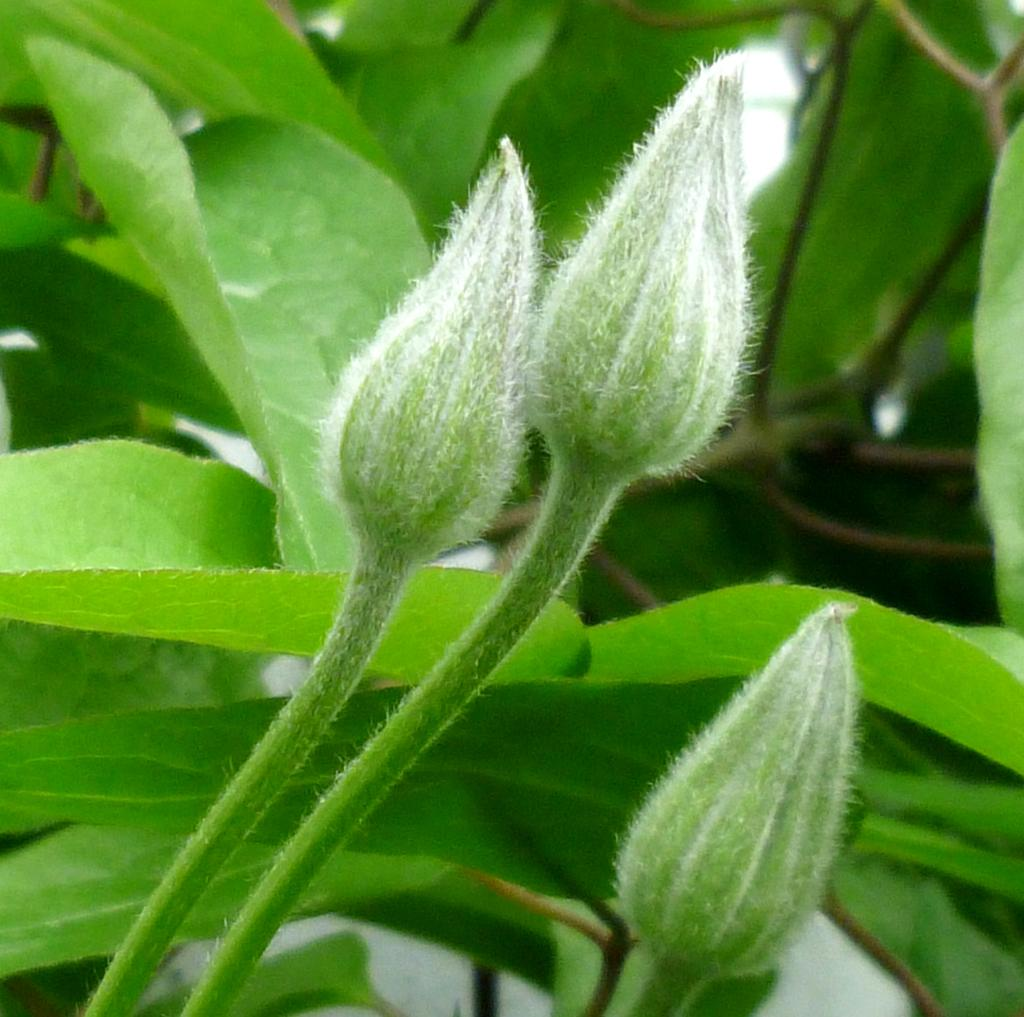What is present in the foreground of the image? There are buds in the foreground of the image. What is visible in the background of the image? There are leaves in the background of the image. What type of cheese can be seen in the image? There is no cheese present in the image. What might surprise someone about the image? The image itself is not surprising, as it simply shows buds in the foreground and leaves in the background. 